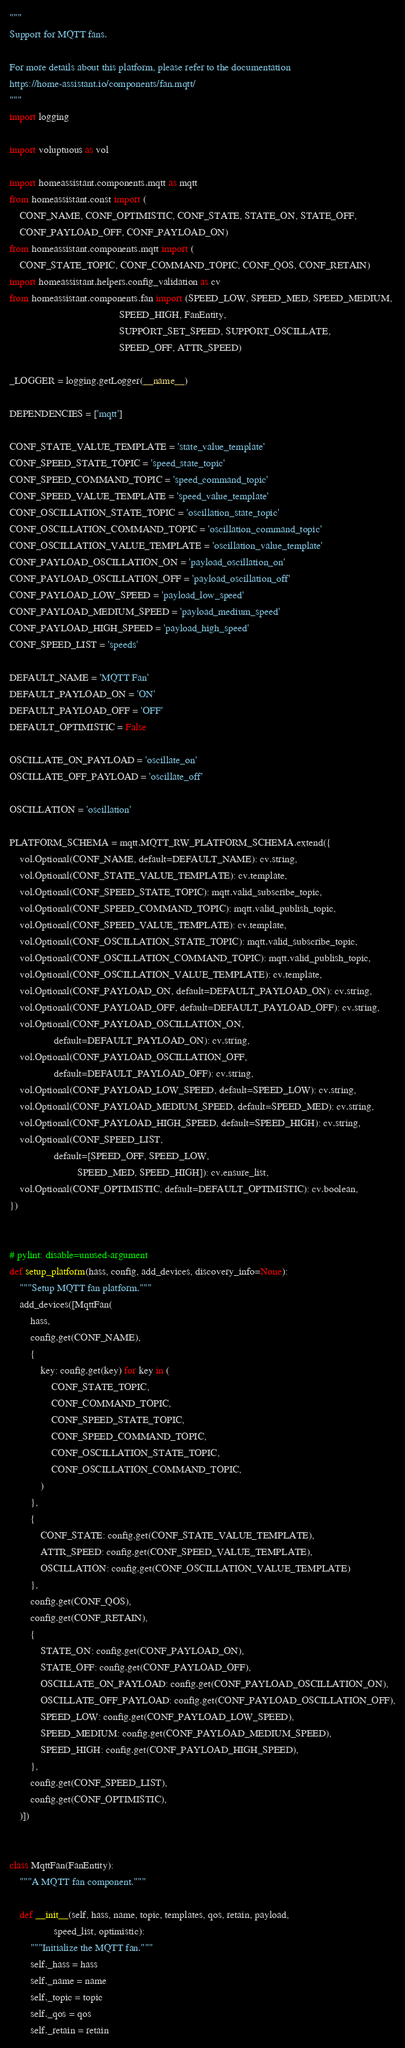<code> <loc_0><loc_0><loc_500><loc_500><_Python_>"""
Support for MQTT fans.

For more details about this platform, please refer to the documentation
https://home-assistant.io/components/fan.mqtt/
"""
import logging

import voluptuous as vol

import homeassistant.components.mqtt as mqtt
from homeassistant.const import (
    CONF_NAME, CONF_OPTIMISTIC, CONF_STATE, STATE_ON, STATE_OFF,
    CONF_PAYLOAD_OFF, CONF_PAYLOAD_ON)
from homeassistant.components.mqtt import (
    CONF_STATE_TOPIC, CONF_COMMAND_TOPIC, CONF_QOS, CONF_RETAIN)
import homeassistant.helpers.config_validation as cv
from homeassistant.components.fan import (SPEED_LOW, SPEED_MED, SPEED_MEDIUM,
                                          SPEED_HIGH, FanEntity,
                                          SUPPORT_SET_SPEED, SUPPORT_OSCILLATE,
                                          SPEED_OFF, ATTR_SPEED)

_LOGGER = logging.getLogger(__name__)

DEPENDENCIES = ['mqtt']

CONF_STATE_VALUE_TEMPLATE = 'state_value_template'
CONF_SPEED_STATE_TOPIC = 'speed_state_topic'
CONF_SPEED_COMMAND_TOPIC = 'speed_command_topic'
CONF_SPEED_VALUE_TEMPLATE = 'speed_value_template'
CONF_OSCILLATION_STATE_TOPIC = 'oscillation_state_topic'
CONF_OSCILLATION_COMMAND_TOPIC = 'oscillation_command_topic'
CONF_OSCILLATION_VALUE_TEMPLATE = 'oscillation_value_template'
CONF_PAYLOAD_OSCILLATION_ON = 'payload_oscillation_on'
CONF_PAYLOAD_OSCILLATION_OFF = 'payload_oscillation_off'
CONF_PAYLOAD_LOW_SPEED = 'payload_low_speed'
CONF_PAYLOAD_MEDIUM_SPEED = 'payload_medium_speed'
CONF_PAYLOAD_HIGH_SPEED = 'payload_high_speed'
CONF_SPEED_LIST = 'speeds'

DEFAULT_NAME = 'MQTT Fan'
DEFAULT_PAYLOAD_ON = 'ON'
DEFAULT_PAYLOAD_OFF = 'OFF'
DEFAULT_OPTIMISTIC = False

OSCILLATE_ON_PAYLOAD = 'oscillate_on'
OSCILLATE_OFF_PAYLOAD = 'oscillate_off'

OSCILLATION = 'oscillation'

PLATFORM_SCHEMA = mqtt.MQTT_RW_PLATFORM_SCHEMA.extend({
    vol.Optional(CONF_NAME, default=DEFAULT_NAME): cv.string,
    vol.Optional(CONF_STATE_VALUE_TEMPLATE): cv.template,
    vol.Optional(CONF_SPEED_STATE_TOPIC): mqtt.valid_subscribe_topic,
    vol.Optional(CONF_SPEED_COMMAND_TOPIC): mqtt.valid_publish_topic,
    vol.Optional(CONF_SPEED_VALUE_TEMPLATE): cv.template,
    vol.Optional(CONF_OSCILLATION_STATE_TOPIC): mqtt.valid_subscribe_topic,
    vol.Optional(CONF_OSCILLATION_COMMAND_TOPIC): mqtt.valid_publish_topic,
    vol.Optional(CONF_OSCILLATION_VALUE_TEMPLATE): cv.template,
    vol.Optional(CONF_PAYLOAD_ON, default=DEFAULT_PAYLOAD_ON): cv.string,
    vol.Optional(CONF_PAYLOAD_OFF, default=DEFAULT_PAYLOAD_OFF): cv.string,
    vol.Optional(CONF_PAYLOAD_OSCILLATION_ON,
                 default=DEFAULT_PAYLOAD_ON): cv.string,
    vol.Optional(CONF_PAYLOAD_OSCILLATION_OFF,
                 default=DEFAULT_PAYLOAD_OFF): cv.string,
    vol.Optional(CONF_PAYLOAD_LOW_SPEED, default=SPEED_LOW): cv.string,
    vol.Optional(CONF_PAYLOAD_MEDIUM_SPEED, default=SPEED_MED): cv.string,
    vol.Optional(CONF_PAYLOAD_HIGH_SPEED, default=SPEED_HIGH): cv.string,
    vol.Optional(CONF_SPEED_LIST,
                 default=[SPEED_OFF, SPEED_LOW,
                          SPEED_MED, SPEED_HIGH]): cv.ensure_list,
    vol.Optional(CONF_OPTIMISTIC, default=DEFAULT_OPTIMISTIC): cv.boolean,
})


# pylint: disable=unused-argument
def setup_platform(hass, config, add_devices, discovery_info=None):
    """Setup MQTT fan platform."""
    add_devices([MqttFan(
        hass,
        config.get(CONF_NAME),
        {
            key: config.get(key) for key in (
                CONF_STATE_TOPIC,
                CONF_COMMAND_TOPIC,
                CONF_SPEED_STATE_TOPIC,
                CONF_SPEED_COMMAND_TOPIC,
                CONF_OSCILLATION_STATE_TOPIC,
                CONF_OSCILLATION_COMMAND_TOPIC,
            )
        },
        {
            CONF_STATE: config.get(CONF_STATE_VALUE_TEMPLATE),
            ATTR_SPEED: config.get(CONF_SPEED_VALUE_TEMPLATE),
            OSCILLATION: config.get(CONF_OSCILLATION_VALUE_TEMPLATE)
        },
        config.get(CONF_QOS),
        config.get(CONF_RETAIN),
        {
            STATE_ON: config.get(CONF_PAYLOAD_ON),
            STATE_OFF: config.get(CONF_PAYLOAD_OFF),
            OSCILLATE_ON_PAYLOAD: config.get(CONF_PAYLOAD_OSCILLATION_ON),
            OSCILLATE_OFF_PAYLOAD: config.get(CONF_PAYLOAD_OSCILLATION_OFF),
            SPEED_LOW: config.get(CONF_PAYLOAD_LOW_SPEED),
            SPEED_MEDIUM: config.get(CONF_PAYLOAD_MEDIUM_SPEED),
            SPEED_HIGH: config.get(CONF_PAYLOAD_HIGH_SPEED),
        },
        config.get(CONF_SPEED_LIST),
        config.get(CONF_OPTIMISTIC),
    )])


class MqttFan(FanEntity):
    """A MQTT fan component."""

    def __init__(self, hass, name, topic, templates, qos, retain, payload,
                 speed_list, optimistic):
        """Initialize the MQTT fan."""
        self._hass = hass
        self._name = name
        self._topic = topic
        self._qos = qos
        self._retain = retain</code> 